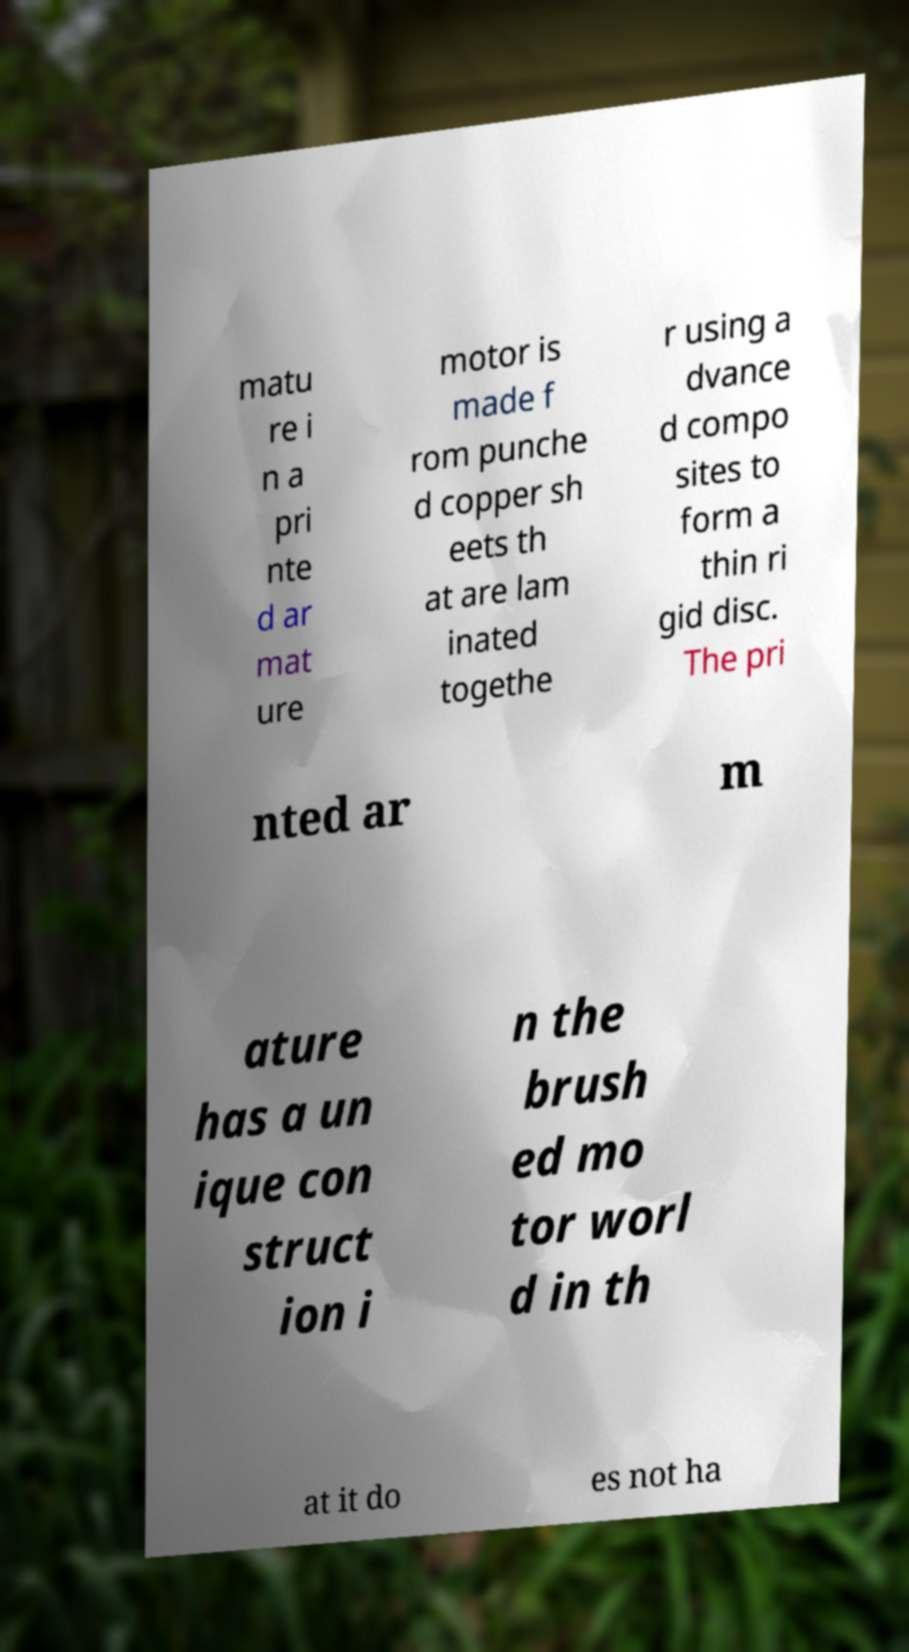Can you accurately transcribe the text from the provided image for me? matu re i n a pri nte d ar mat ure motor is made f rom punche d copper sh eets th at are lam inated togethe r using a dvance d compo sites to form a thin ri gid disc. The pri nted ar m ature has a un ique con struct ion i n the brush ed mo tor worl d in th at it do es not ha 